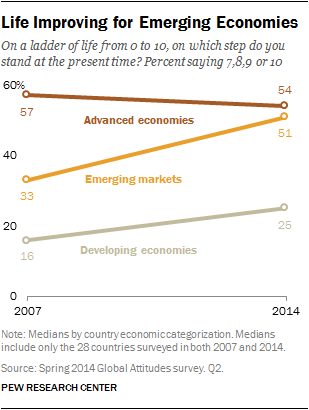Specify some key components in this picture. In 2014, the value of developing economies was 25%. The average of all the values in 2007 is less than the average of all the values in 2014. 